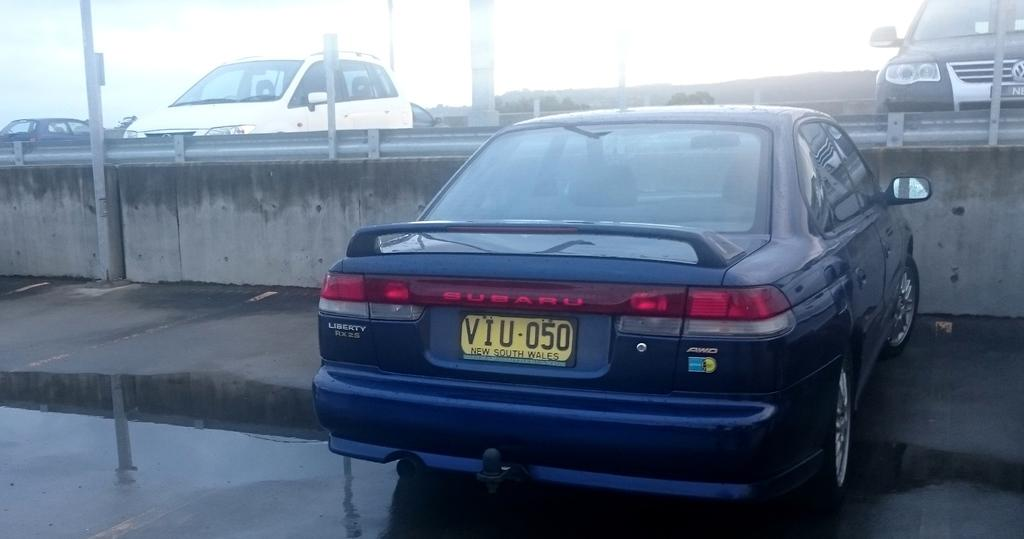What type of vehicles can be seen in the image? There are cars in the image. What else is present in the image besides the cars? There are poles in the image. Can you describe the number plate on one of the cars? The number plate on a car is yellow in color. What is written or displayed on the number plate? Something is written on the number plate. How does the tongue help in the destruction of the car in the image? There is no tongue or destruction present in the image. The image only shows cars and poles. 